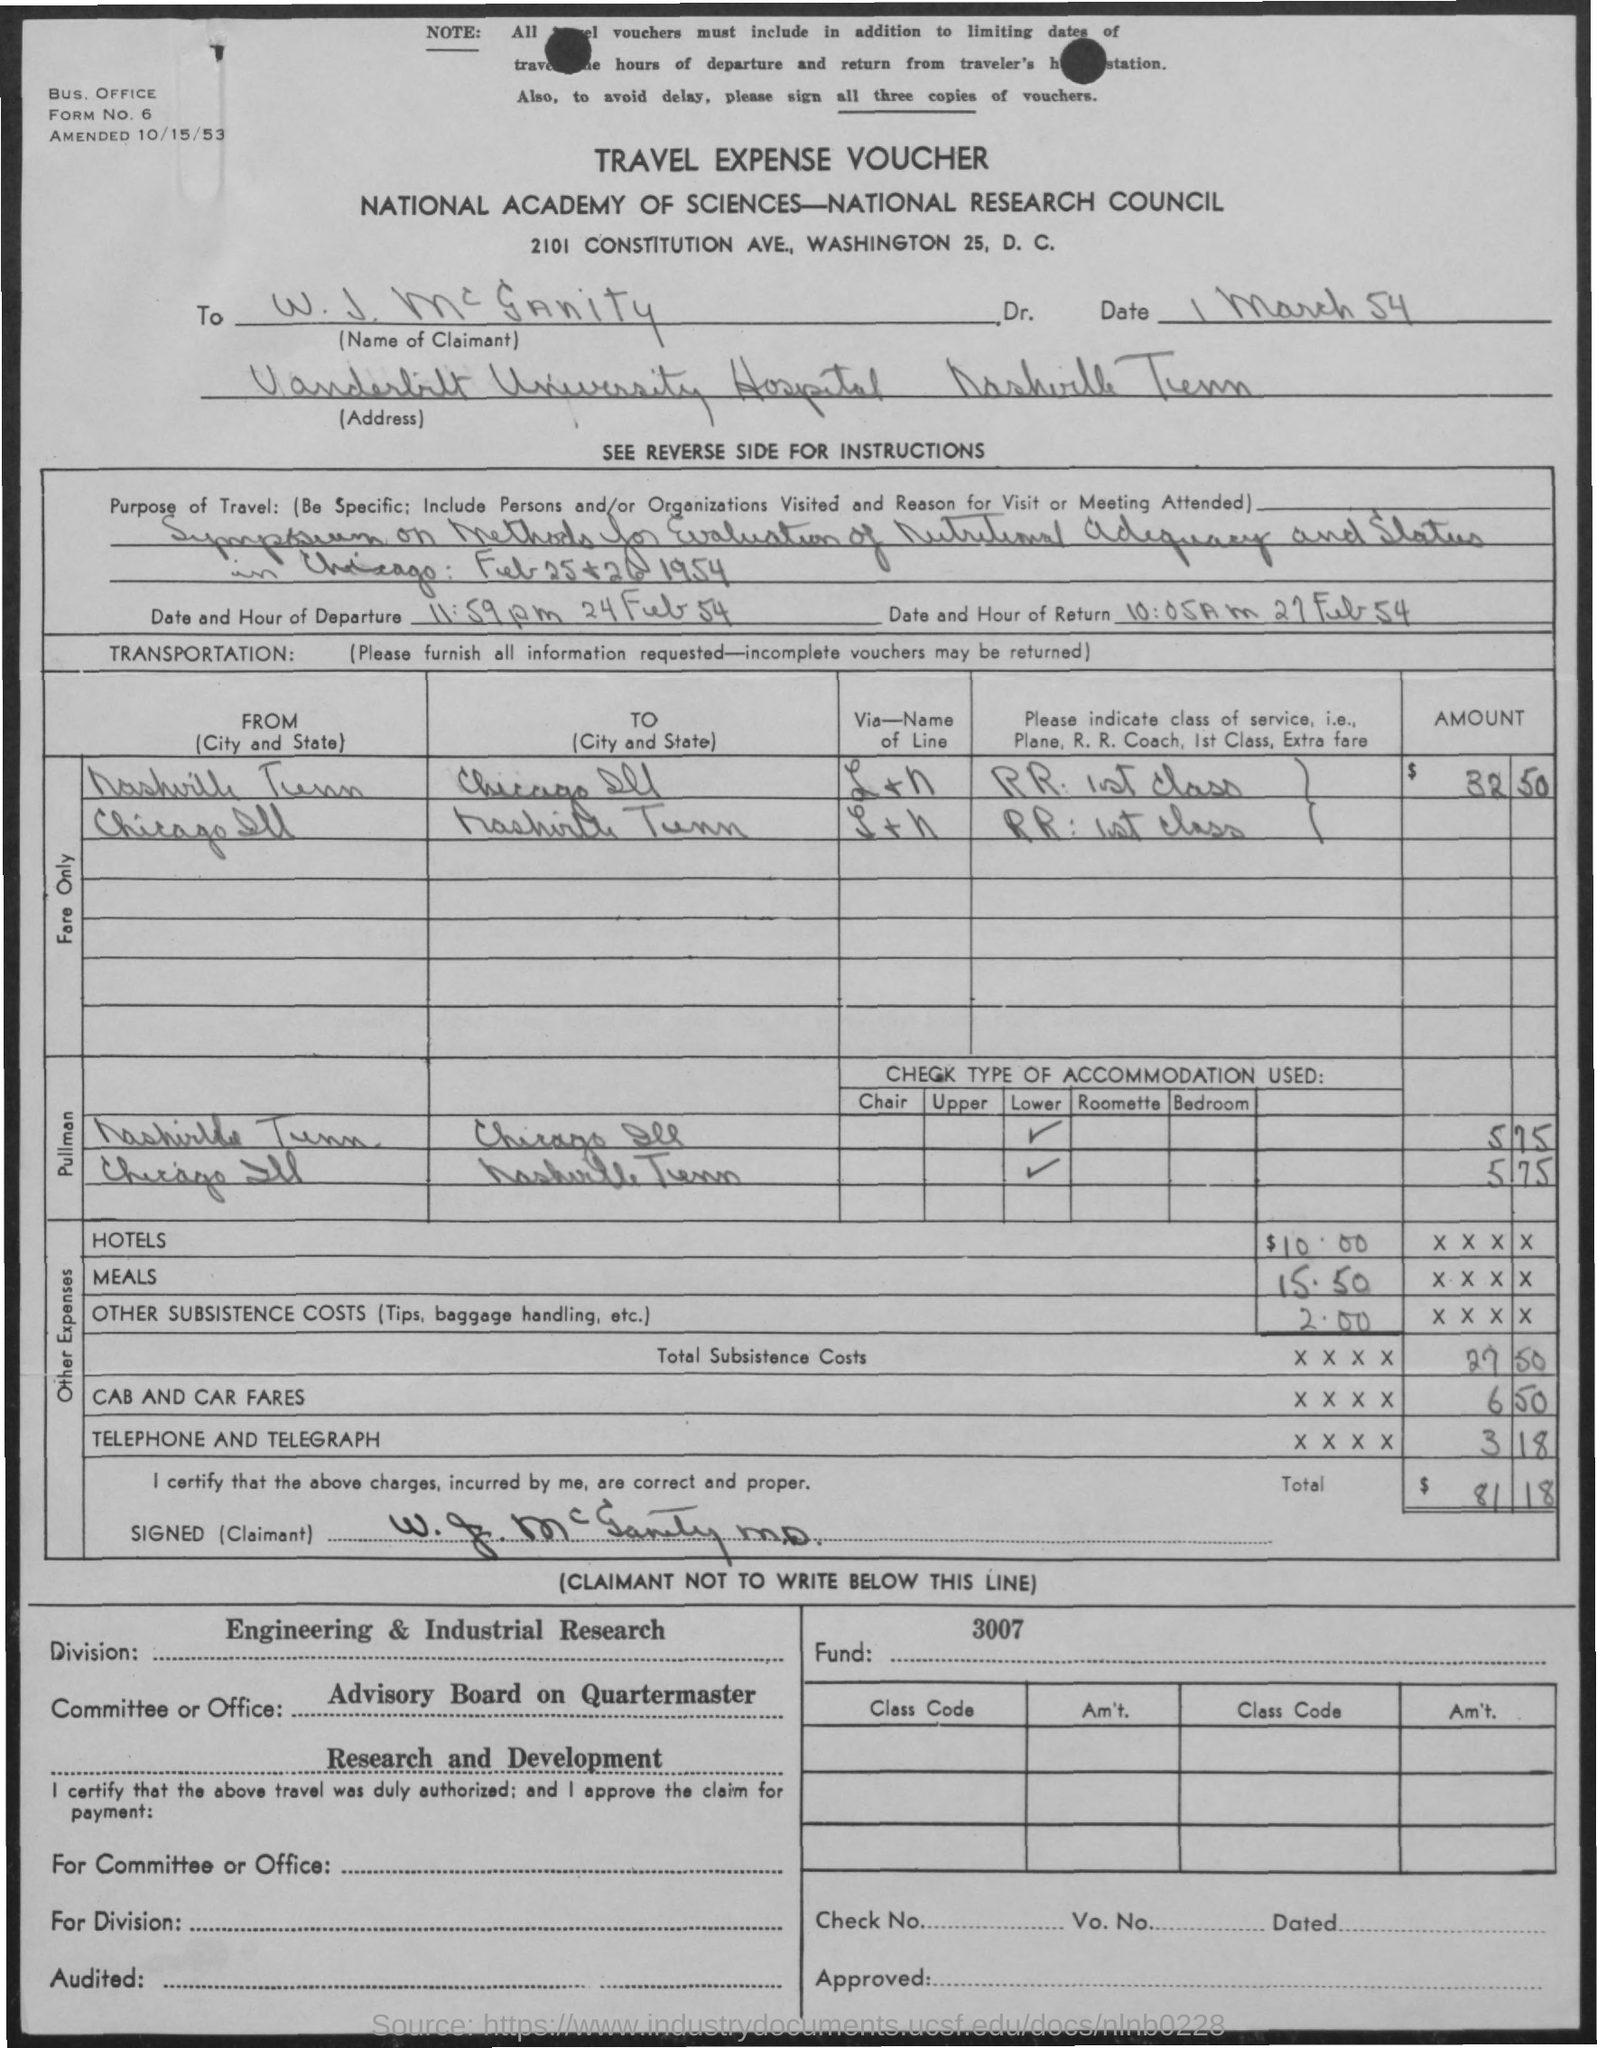Draw attention to some important aspects in this diagram. The amount for the hotels mentioned in the given voucher is $10.00. The voucher in question is referred to as a 'travel expense voucher.' The date and hour of return mentioned in the given form is 10:05 AM on February 27, 1954. What is the date of the amendment? On October 15, 1953. The given voucher mentions a total amount of 81.18. 